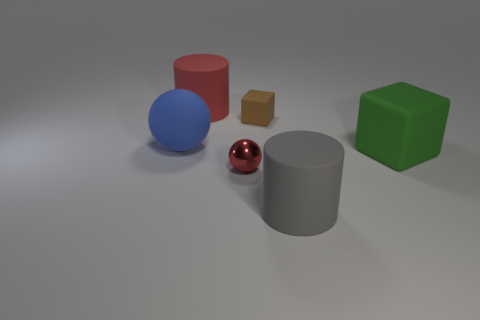There is a gray cylinder; what number of red spheres are behind it?
Provide a short and direct response. 1. How many things are large rubber cubes or rubber things?
Provide a short and direct response. 5. What is the shape of the object that is to the left of the brown thing and in front of the big rubber sphere?
Offer a terse response. Sphere. What number of blue shiny things are there?
Offer a very short reply. 0. There is a tiny block that is made of the same material as the blue thing; what color is it?
Ensure brevity in your answer.  Brown. Is the number of large cylinders greater than the number of objects?
Provide a succinct answer. No. There is a object that is to the left of the small matte object and behind the large blue rubber sphere; what size is it?
Your answer should be compact. Large. There is another thing that is the same color as the metal object; what material is it?
Offer a terse response. Rubber. Is the number of gray rubber cylinders on the left side of the blue matte thing the same as the number of green matte cubes?
Provide a succinct answer. No. Is the size of the blue rubber ball the same as the gray matte object?
Offer a very short reply. Yes. 